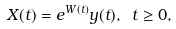Convert formula to latex. <formula><loc_0><loc_0><loc_500><loc_500>X ( t ) = e ^ { W ( t ) } y ( t ) , \ t \geq 0 ,</formula> 